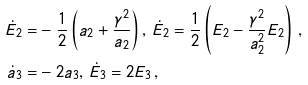<formula> <loc_0><loc_0><loc_500><loc_500>\dot { E } _ { 2 } = & - \frac { 1 } { 2 } \left ( a _ { 2 } + \frac { \gamma ^ { 2 } } { a _ { 2 } } \right ) , \, \dot { E } _ { 2 } = \frac { 1 } { 2 } \left ( E _ { 2 } - \frac { \gamma ^ { 2 } } { a _ { 2 } ^ { 2 } } E _ { 2 } \right ) \, , \\ \dot { a } _ { 3 } = & - 2 a _ { 3 } , \, \dot { E } _ { 3 } = 2 E _ { 3 } \, ,</formula> 